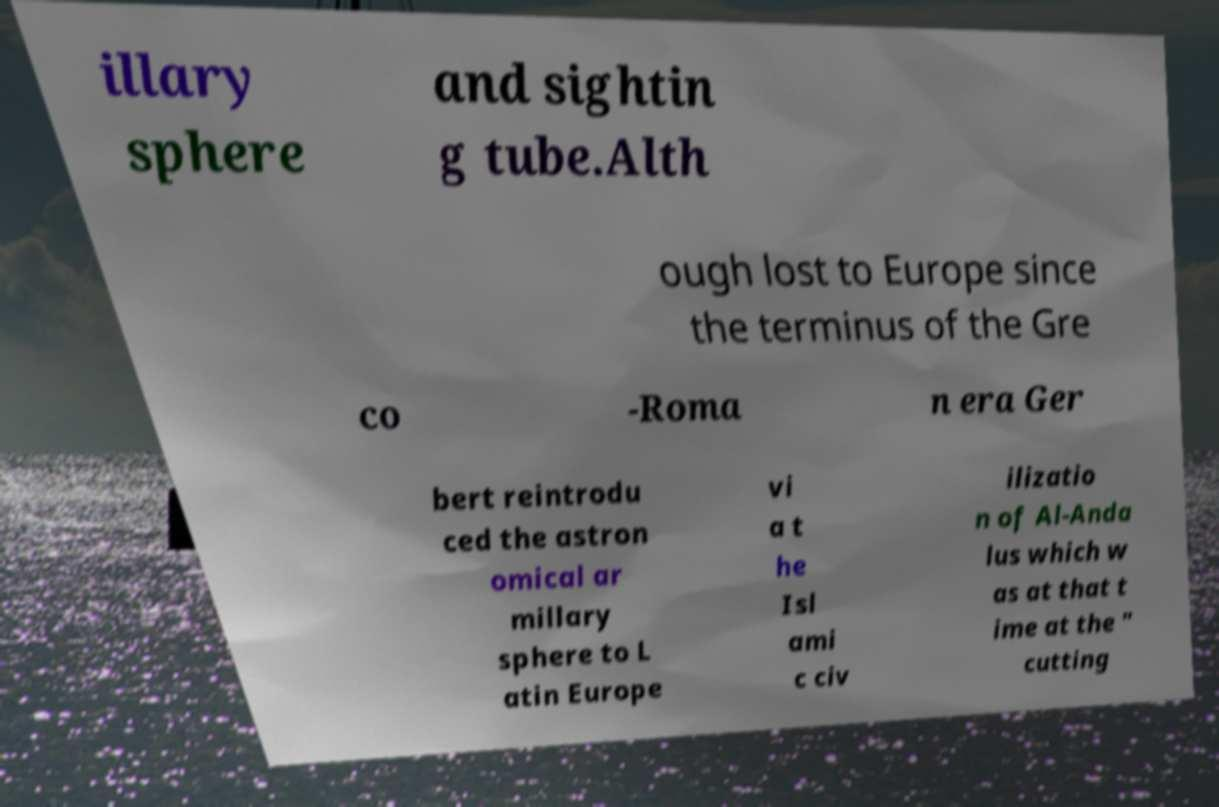Please identify and transcribe the text found in this image. illary sphere and sightin g tube.Alth ough lost to Europe since the terminus of the Gre co -Roma n era Ger bert reintrodu ced the astron omical ar millary sphere to L atin Europe vi a t he Isl ami c civ ilizatio n of Al-Anda lus which w as at that t ime at the " cutting 